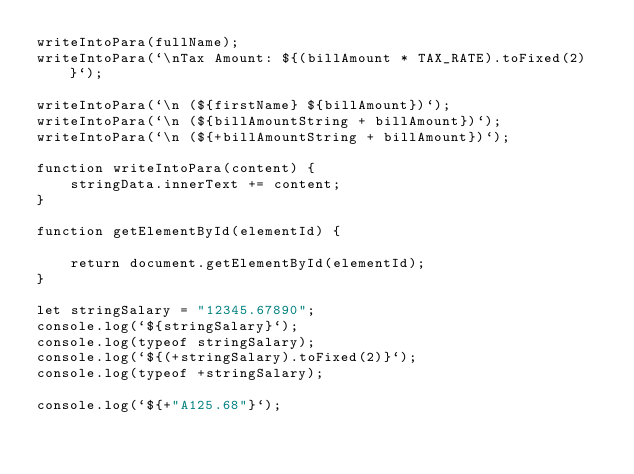Convert code to text. <code><loc_0><loc_0><loc_500><loc_500><_JavaScript_>writeIntoPara(fullName);
writeIntoPara(`\nTax Amount: ${(billAmount * TAX_RATE).toFixed(2)}`);

writeIntoPara(`\n (${firstName} ${billAmount})`);
writeIntoPara(`\n (${billAmountString + billAmount})`);
writeIntoPara(`\n (${+billAmountString + billAmount})`);

function writeIntoPara(content) {
    stringData.innerText += content;
}

function getElementById(elementId) {

    return document.getElementById(elementId);
}

let stringSalary = "12345.67890";
console.log(`${stringSalary}`);
console.log(typeof stringSalary);
console.log(`${(+stringSalary).toFixed(2)}`);
console.log(typeof +stringSalary);

console.log(`${+"A125.68"}`);
</code> 